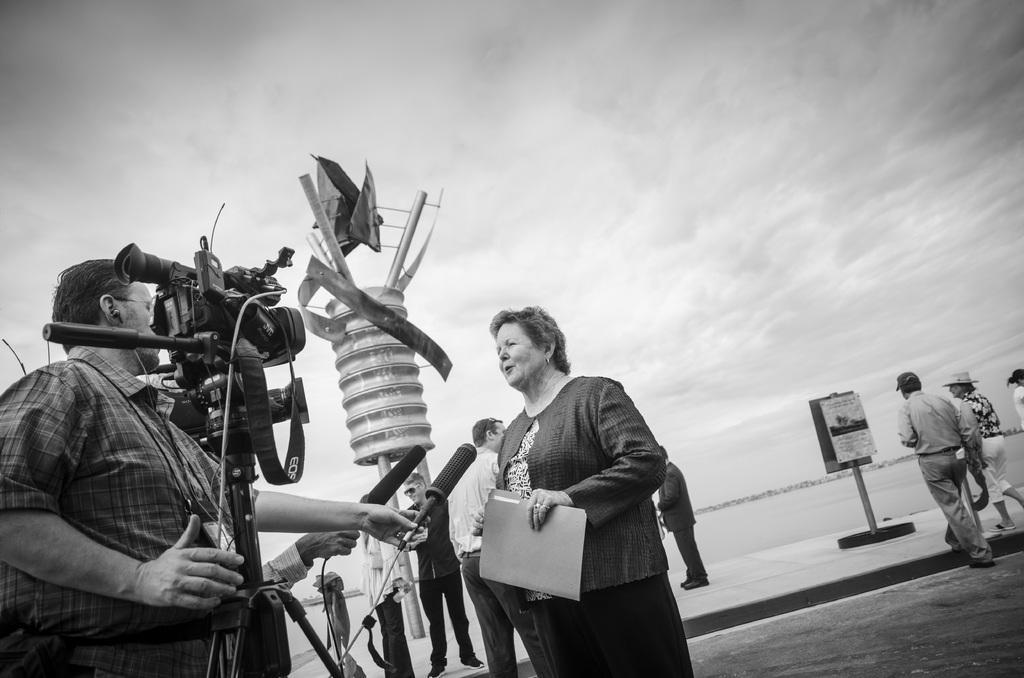In one or two sentences, can you explain what this image depicts? In the image we can see there are people who are standing and the man is holding a video camera in his hand and people are holding mic in their hand and the image is in black and white colour. 